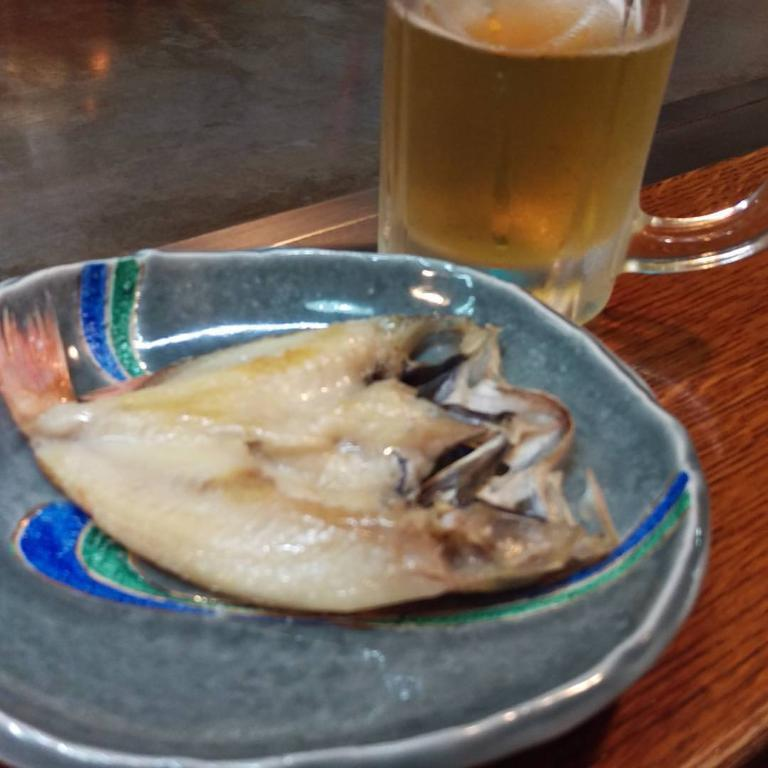What is on the plate that is visible in the image? There is a plate with fish in the image. What is in the glass that is visible in the image? There is a glass with liquid in the image. What color is the table in the image? The table is brown. How would you describe the background of the image? The background of the image is blurred. What type of spot is visible on the fish in the image? There are no spots visible on the fish in the image. Is there a veil covering the glass in the image? There is no veil present in the image; the glass is visible. 